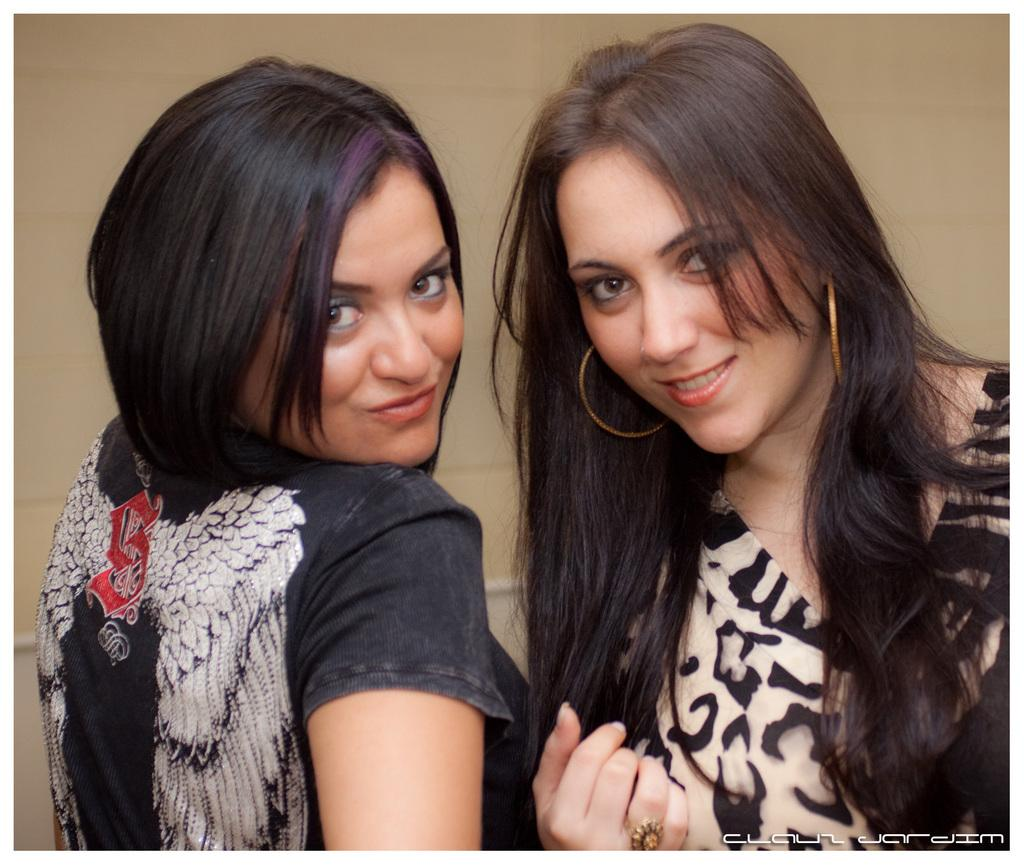How many women are in the image? There are two women in the image. What are the women wearing? The women are wearing dresses. What expression do the women have? The women are smiling. What can be seen in the background of the image? There is a wall in the background of the image. What type of train can be seen passing by in the image? There is no train present in the image. What color is the chance in the image? The term "chance" does not refer to a specific object or color, and there is no such element in the image. 